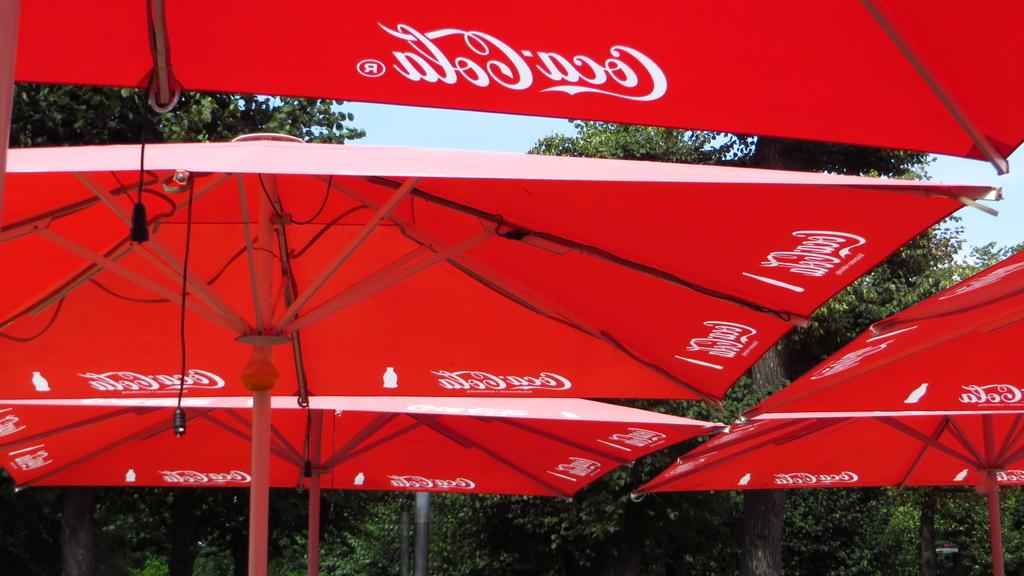What brand is associated with the umbrellas in the image? The umbrellas in the image have the Coca Cola name. What can be seen behind the umbrellas in the image? There are trees visible behind the umbrellas. Reasoning: Let's think step by step by step in order to produce the conversation. We start by identifying the main subject in the image, which is the umbrellas with the Coca Cola name. Then, we expand the conversation to include other items that are also visible, such as the trees behind the umbrellas. Each question is designed to elicit a specific detail about the image that is known from the provided facts. Absurd Question/Answer: What type of brass instrument can be heard playing in the background of the image? There is no brass instrument or sound present in the image; it only features umbrellas with the Coca Cola name and trees behind them. What type of brass instrument can be heard playing in the background of the image? There is no brass instrument or sound present in the image; it only features umbrellas with the Coca Cola name and trees behind them. 